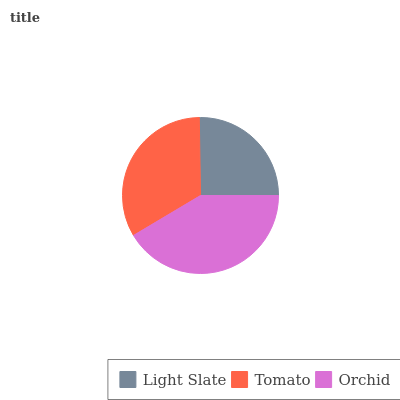Is Light Slate the minimum?
Answer yes or no. Yes. Is Orchid the maximum?
Answer yes or no. Yes. Is Tomato the minimum?
Answer yes or no. No. Is Tomato the maximum?
Answer yes or no. No. Is Tomato greater than Light Slate?
Answer yes or no. Yes. Is Light Slate less than Tomato?
Answer yes or no. Yes. Is Light Slate greater than Tomato?
Answer yes or no. No. Is Tomato less than Light Slate?
Answer yes or no. No. Is Tomato the high median?
Answer yes or no. Yes. Is Tomato the low median?
Answer yes or no. Yes. Is Orchid the high median?
Answer yes or no. No. Is Orchid the low median?
Answer yes or no. No. 